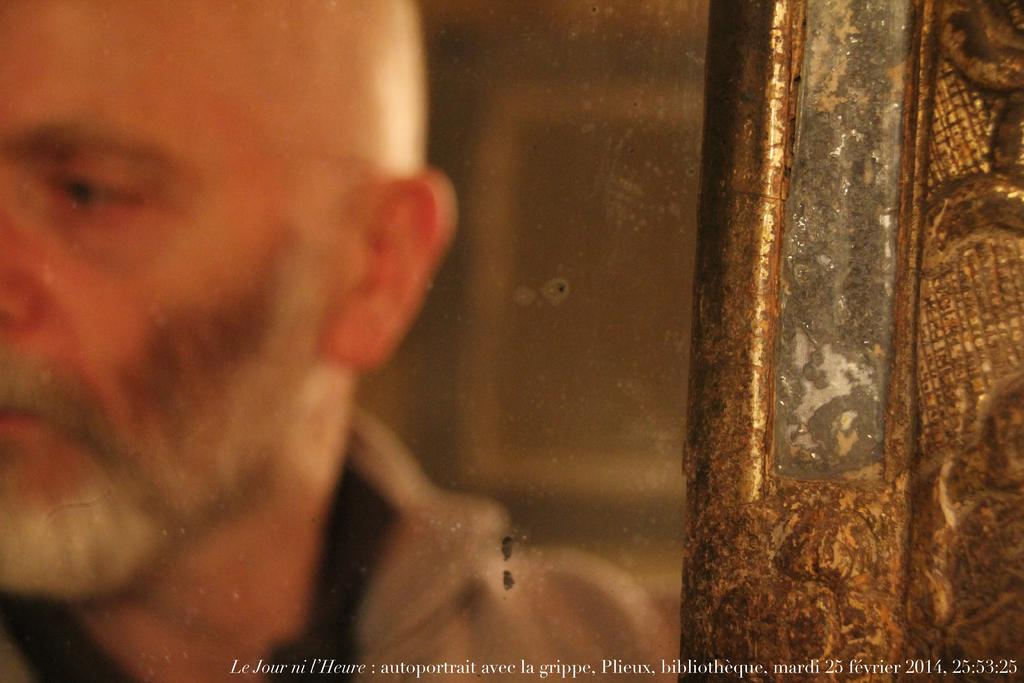Who is present in the image? There is a man in the image. Can you describe the background of the image? The background of the image is blurry. What can be seen at the bottom of the image? There is text visible at the bottom of the image. Is there a ghost visible in the image? No, there is no ghost present in the image. What type of umbrella is the man holding in the image? There is no umbrella present in the image. 